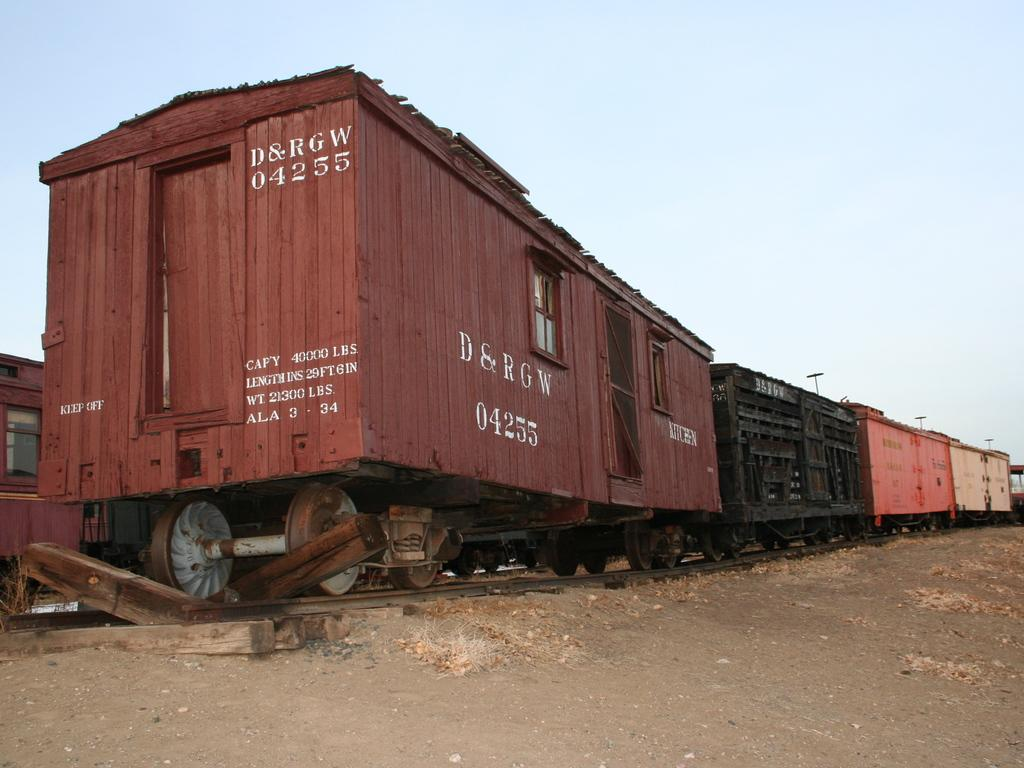What type of train is in the image? There is a goods train in the image. Where is the train located? The train is on a track. What can be seen through the window in the image? The image does not show a window that we can look through. What is visible on the ground in the image? The ground is visible in the image, but there is no specific detail about what is on the ground. What is visible in the sky in the image? The sky is visible in the image, but there is no specific detail about what is in the sky. What type of nut is being used to steer the ship in the image? There is no ship or nut present in the image; it features a goods train on a track. 